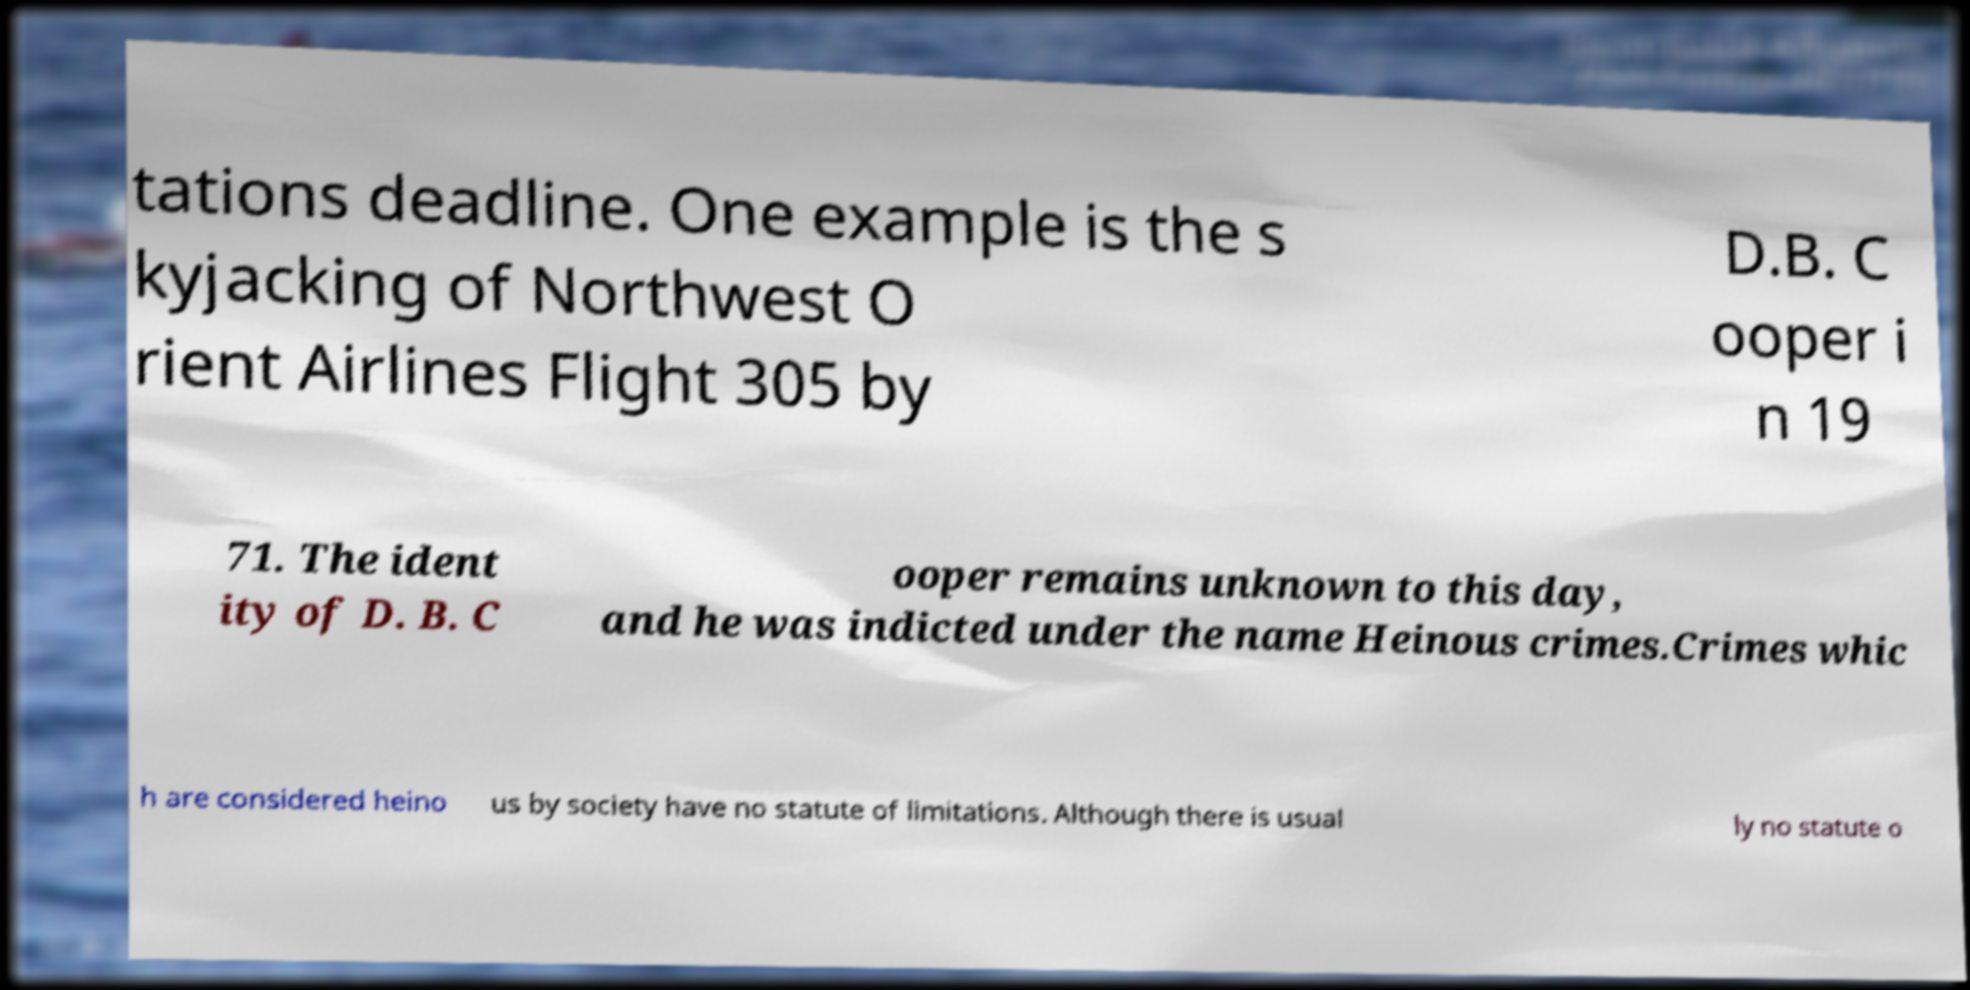Could you assist in decoding the text presented in this image and type it out clearly? tations deadline. One example is the s kyjacking of Northwest O rient Airlines Flight 305 by D.B. C ooper i n 19 71. The ident ity of D. B. C ooper remains unknown to this day, and he was indicted under the name Heinous crimes.Crimes whic h are considered heino us by society have no statute of limitations. Although there is usual ly no statute o 